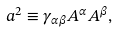Convert formula to latex. <formula><loc_0><loc_0><loc_500><loc_500>a ^ { 2 } \equiv \gamma _ { \alpha \beta } A ^ { \alpha } A ^ { \beta } ,</formula> 